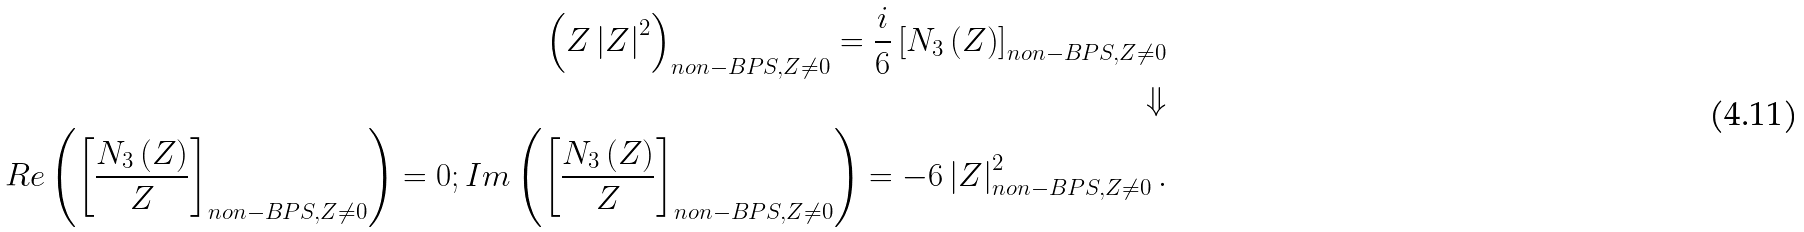Convert formula to latex. <formula><loc_0><loc_0><loc_500><loc_500>\left ( Z \left | Z \right | ^ { 2 } \right ) _ { n o n - B P S , Z \neq 0 } = \frac { i } { 6 } \left [ N _ { 3 } \left ( Z \right ) \right ] _ { n o n - B P S , Z \neq 0 } \\ \Downarrow \\ R e \left ( \left [ \frac { N _ { 3 } \left ( Z \right ) } { Z } \right ] _ { n o n - B P S , Z \neq 0 } \right ) = 0 ; I m \left ( \left [ \frac { N _ { 3 } \left ( Z \right ) } { Z } \right ] _ { n o n - B P S , Z \neq 0 } \right ) = - 6 \left | Z \right | _ { n o n - B P S , Z \neq 0 } ^ { 2 } .</formula> 